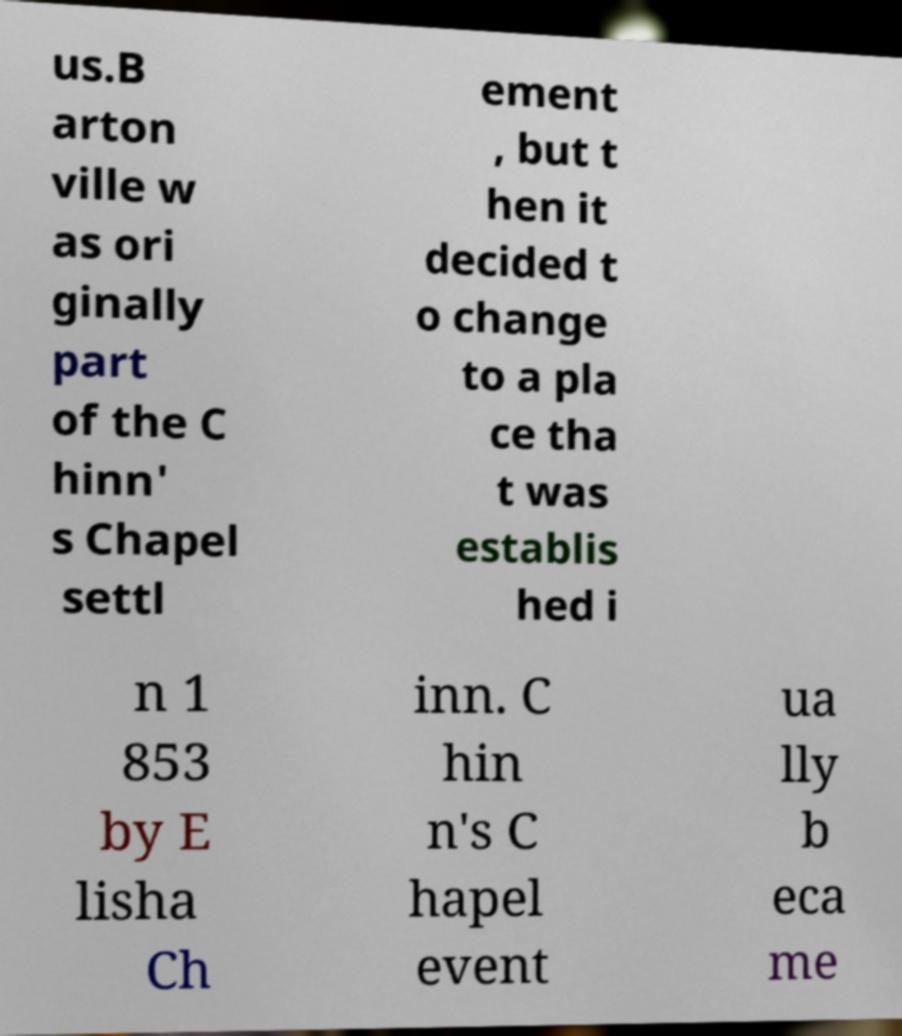Could you assist in decoding the text presented in this image and type it out clearly? us.B arton ville w as ori ginally part of the C hinn' s Chapel settl ement , but t hen it decided t o change to a pla ce tha t was establis hed i n 1 853 by E lisha Ch inn. C hin n's C hapel event ua lly b eca me 